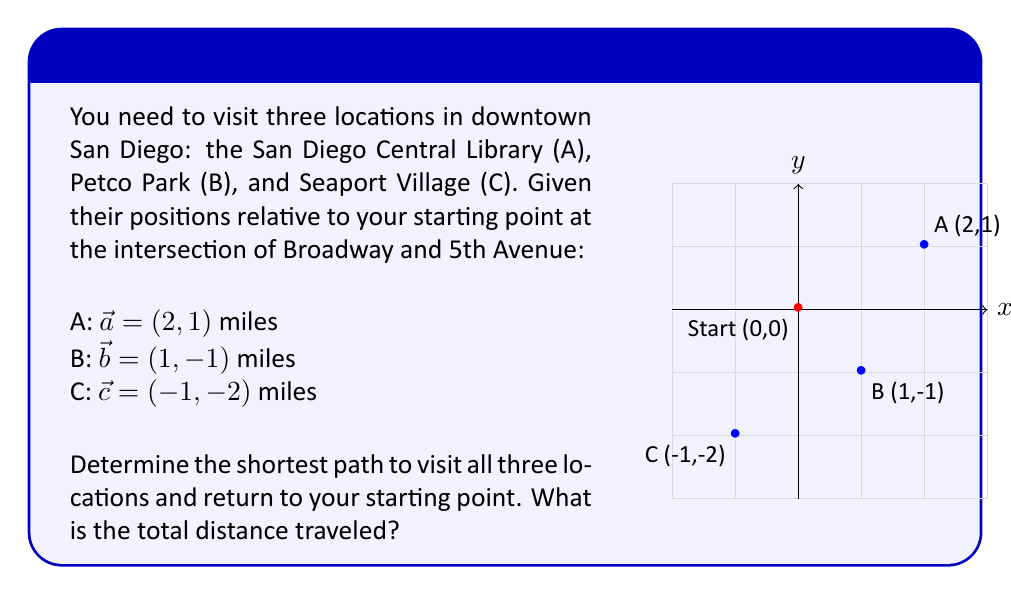Can you solve this math problem? To find the shortest path, we need to calculate the distances between all points and determine the optimal route. Let's follow these steps:

1) Calculate the distances between all points:
   Start to A: $|\vec{a}| = \sqrt{2^2 + 1^2} = \sqrt{5}$ miles
   Start to B: $|\vec{b}| = \sqrt{1^2 + (-1)^2} = \sqrt{2}$ miles
   Start to C: $|\vec{c}| = \sqrt{(-1)^2 + (-2)^2} = \sqrt{5}$ miles
   A to B: $|\vec{b} - \vec{a}| = |(1-2, -1-1)| = |(1,2)| = \sqrt{5}$ miles
   B to C: $|\vec{c} - \vec{b}| = |(-1-1, -2+1)| = |(-2,-1)| = \sqrt{5}$ miles
   C to A: $|\vec{a} - \vec{c}| = |(2+1, 1+2)| = |(3,3)| = 3\sqrt{2}$ miles

2) The shortest path will be the one that minimizes the total distance. We need to consider all possible routes:
   Start -> A -> B -> C -> Start
   Start -> A -> C -> B -> Start
   Start -> B -> A -> C -> Start
   Start -> B -> C -> A -> Start
   Start -> C -> A -> B -> Start
   Start -> C -> B -> A -> Start

3) Calculate the total distance for each route:
   Start -> A -> B -> C -> Start = $\sqrt{5} + \sqrt{5} + \sqrt{5} + \sqrt{5} = 4\sqrt{5}$ miles
   Start -> A -> C -> B -> Start = $\sqrt{5} + 3\sqrt{2} + \sqrt{5} + \sqrt{2} = 2\sqrt{5} + 4\sqrt{2}$ miles
   Start -> B -> A -> C -> Start = $\sqrt{2} + \sqrt{5} + 3\sqrt{2} + \sqrt{5} = 2\sqrt{5} + 4\sqrt{2}$ miles
   Start -> B -> C -> A -> Start = $\sqrt{2} + \sqrt{5} + 3\sqrt{2} + \sqrt{5} = 2\sqrt{5} + 4\sqrt{2}$ miles
   Start -> C -> A -> B -> Start = $\sqrt{5} + 3\sqrt{2} + \sqrt{5} + \sqrt{2} = 2\sqrt{5} + 4\sqrt{2}$ miles
   Start -> C -> B -> A -> Start = $\sqrt{5} + \sqrt{5} + \sqrt{5} + \sqrt{5} = 4\sqrt{5}$ miles

4) The shortest path is either Start -> A -> B -> C -> Start or Start -> C -> B -> A -> Start, both with a total distance of $4\sqrt{5}$ miles.
Answer: $4\sqrt{5}$ miles 